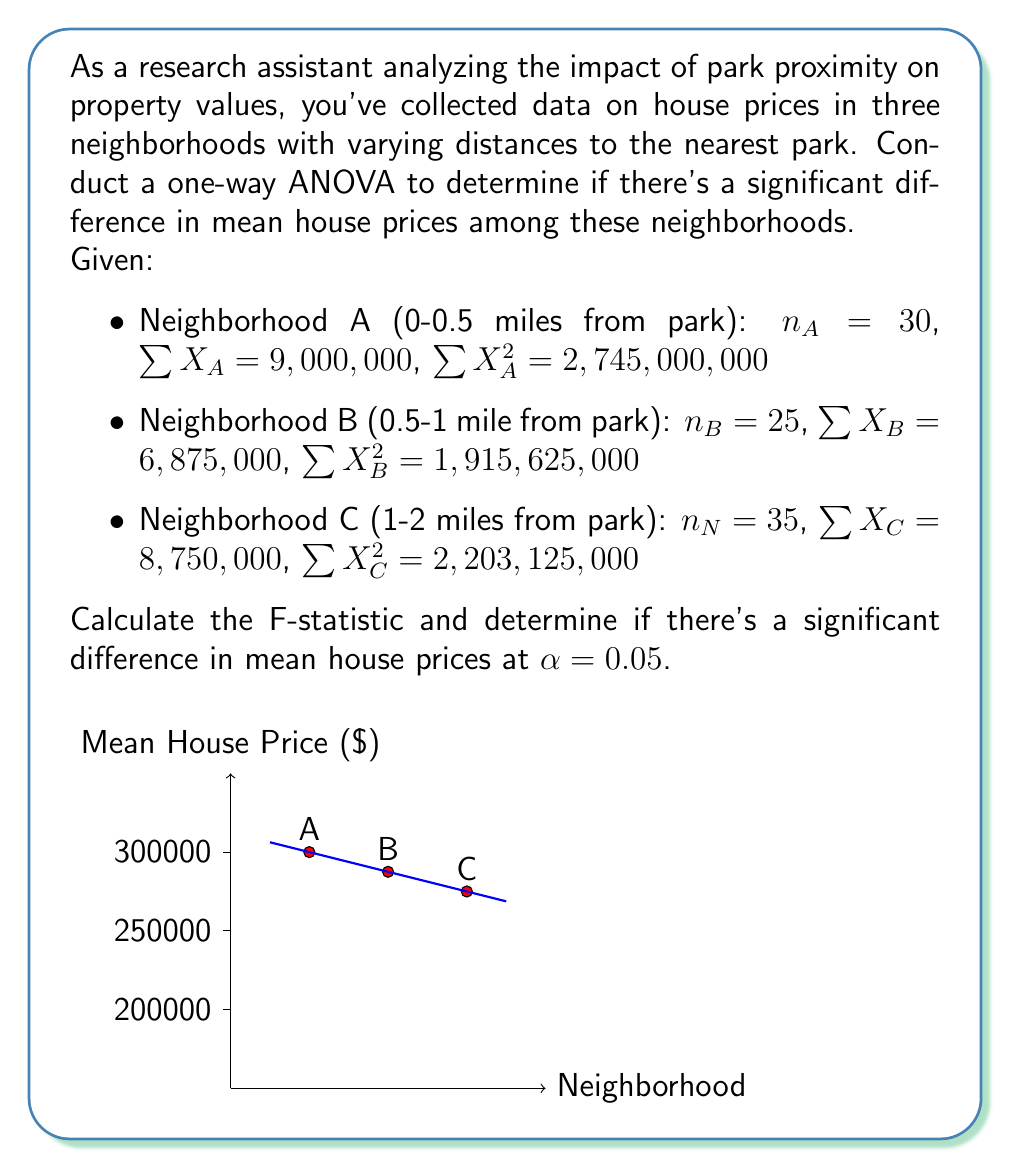Show me your answer to this math problem. Let's solve this step-by-step:

1) Calculate the means for each group:
   $$\bar{X}_A = \frac{9,000,000}{30} = 300,000$$
   $$\bar{X}_B = \frac{6,875,000}{25} = 275,000$$
   $$\bar{X}_C = \frac{8,750,000}{35} = 250,000$$

2) Calculate the overall mean:
   $$\bar{X} = \frac{9,000,000 + 6,875,000 + 8,750,000}{30 + 25 + 35} = \frac{24,625,000}{90} = 273,611.11$$

3) Calculate SST (Total Sum of Squares):
   $$SST = \sum{X^2} - \frac{(\sum{X})^2}{N} = (2,745,000,000 + 1,915,625,000 + 2,203,125,000) - \frac{24,625,000^2}{90} = 6,863,750,000 - 6,738,368,055.56 = 125,381,944.44$$

4) Calculate SSB (Between-group Sum of Squares):
   $$SSB = \sum{n_i(\bar{X}_i - \bar{X})^2} = 30(300,000 - 273,611.11)^2 + 25(275,000 - 273,611.11)^2 + 35(250,000 - 273,611.11)^2 = 52,256,944.44$$

5) Calculate SSW (Within-group Sum of Squares):
   $$SSW = SST - SSB = 125,381,944.44 - 52,256,944.44 = 73,125,000$$

6) Calculate degrees of freedom:
   $$df_{between} = k - 1 = 3 - 1 = 2$$
   $$df_{within} = N - k = 90 - 3 = 87$$

7) Calculate Mean Square Between (MSB) and Mean Square Within (MSW):
   $$MSB = \frac{SSB}{df_{between}} = \frac{52,256,944.44}{2} = 26,128,472.22$$
   $$MSW = \frac{SSW}{df_{within}} = \frac{73,125,000}{87} = 840,517.24$$

8) Calculate F-statistic:
   $$F = \frac{MSB}{MSW} = \frac{26,128,472.22}{840,517.24} = 31.09$$

9) Compare F-statistic to critical value:
   At $\alpha = 0.05$, $F_{critical}(2,87) \approx 3.10$
   Since $31.09 > 3.10$, we reject the null hypothesis.
Answer: $F = 31.09$; significant difference in mean house prices (p < 0.05) 